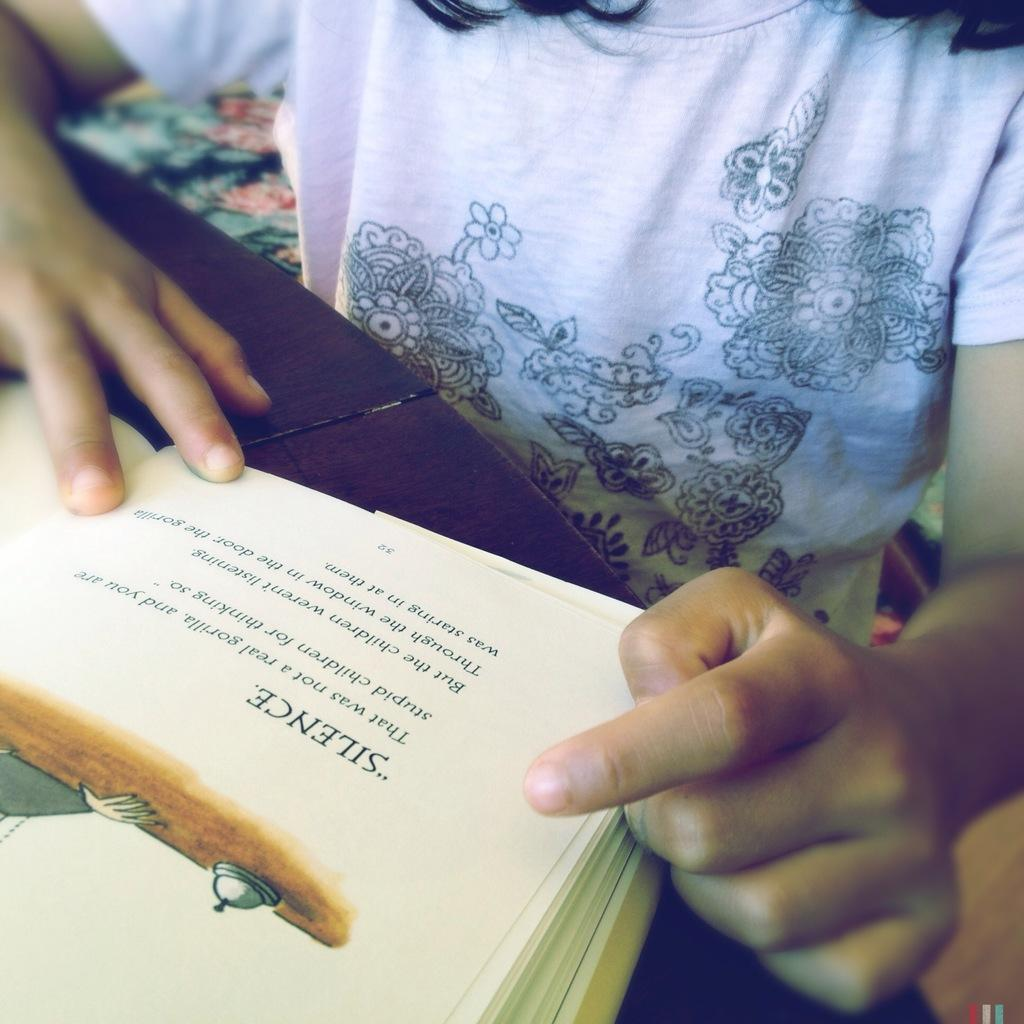Provide a one-sentence caption for the provided image. A young person reading a book with the word Silence at the top. 